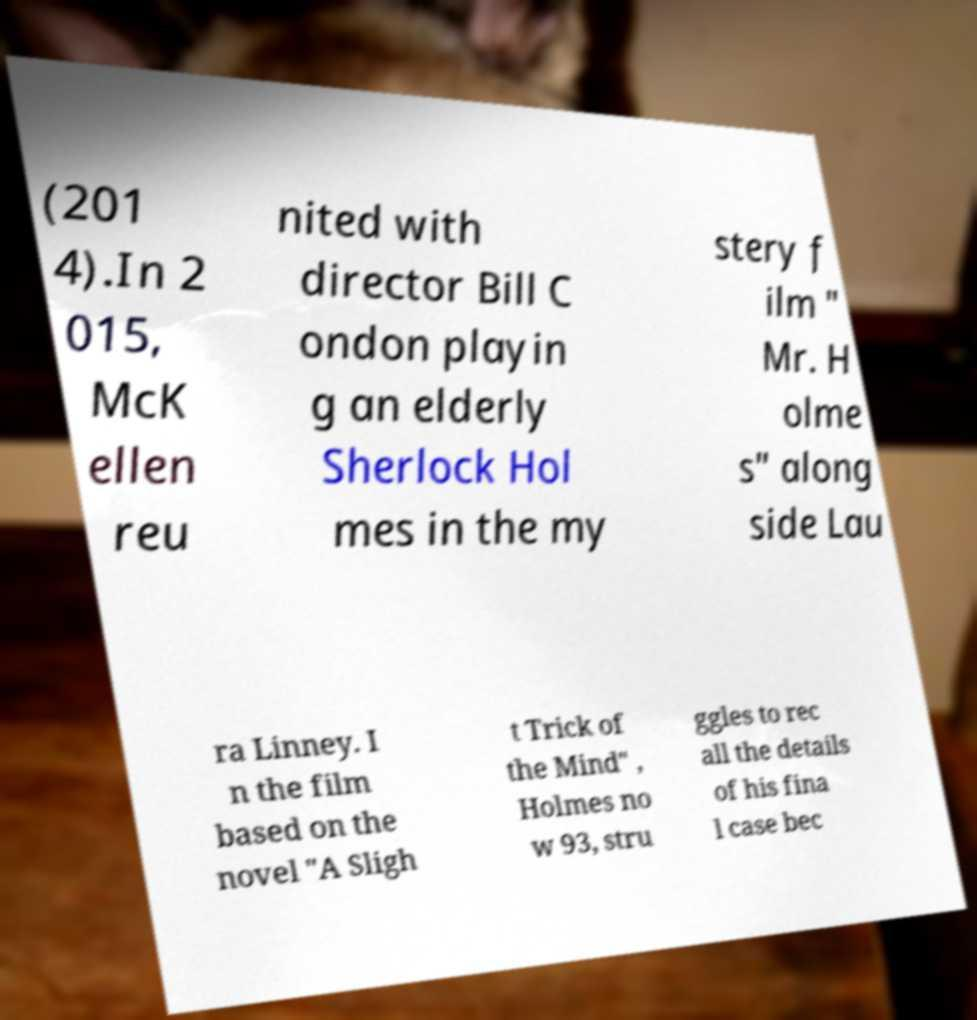Could you assist in decoding the text presented in this image and type it out clearly? (201 4).In 2 015, McK ellen reu nited with director Bill C ondon playin g an elderly Sherlock Hol mes in the my stery f ilm " Mr. H olme s" along side Lau ra Linney. I n the film based on the novel "A Sligh t Trick of the Mind" , Holmes no w 93, stru ggles to rec all the details of his fina l case bec 